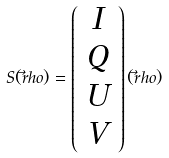<formula> <loc_0><loc_0><loc_500><loc_500>S ( \vec { r } h o ) = \left ( \begin{array} { c } I \\ Q \\ U \\ V \end{array} \right ) ( \vec { r } h o )</formula> 